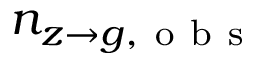<formula> <loc_0><loc_0><loc_500><loc_500>n _ { z \to g , o b s }</formula> 